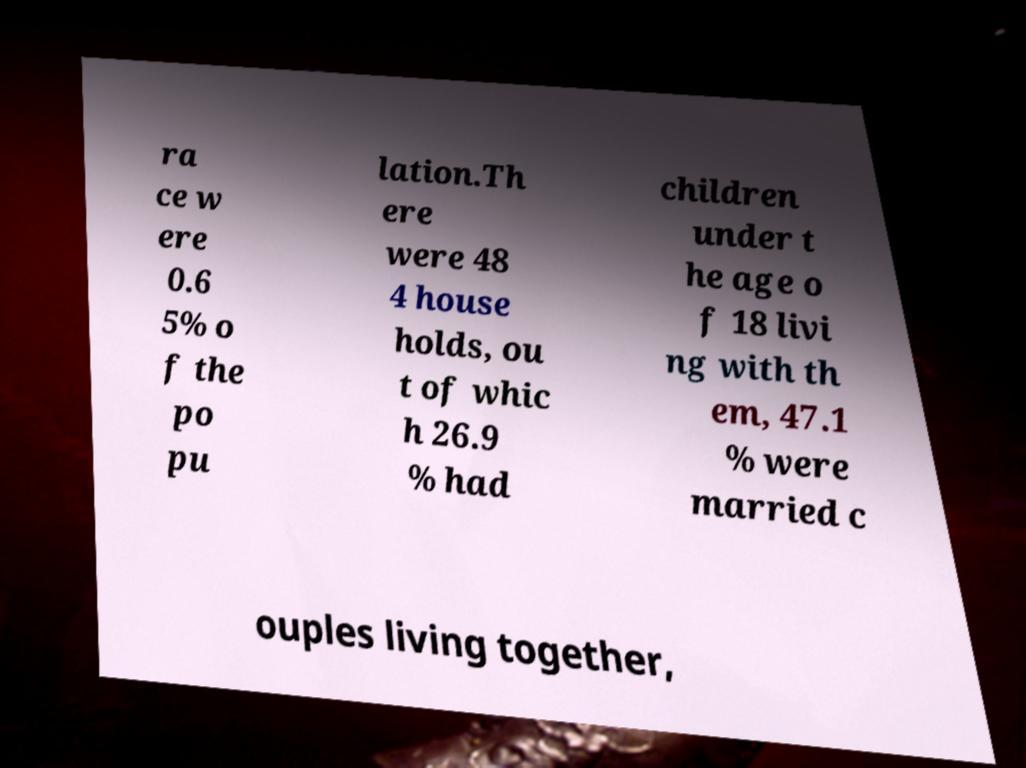What messages or text are displayed in this image? I need them in a readable, typed format. ra ce w ere 0.6 5% o f the po pu lation.Th ere were 48 4 house holds, ou t of whic h 26.9 % had children under t he age o f 18 livi ng with th em, 47.1 % were married c ouples living together, 